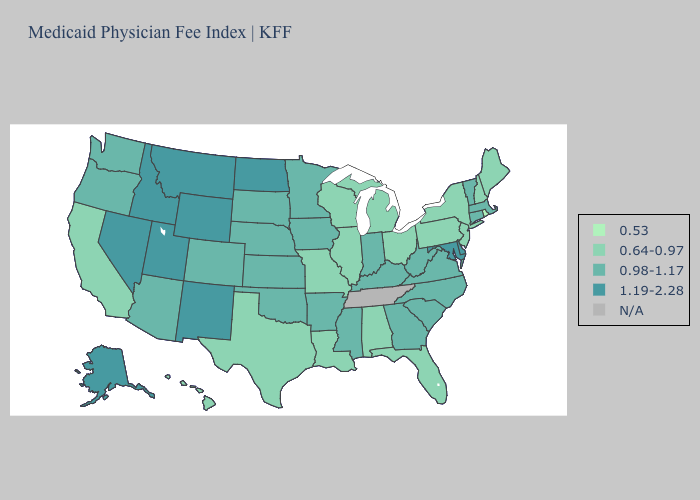Does the map have missing data?
Give a very brief answer. Yes. Does North Dakota have the highest value in the MidWest?
Give a very brief answer. Yes. Among the states that border New Mexico , does Utah have the lowest value?
Quick response, please. No. Among the states that border Delaware , which have the highest value?
Be succinct. Maryland. What is the highest value in the West ?
Be succinct. 1.19-2.28. Name the states that have a value in the range 1.19-2.28?
Be succinct. Alaska, Delaware, Idaho, Maryland, Montana, Nevada, New Mexico, North Dakota, Utah, Wyoming. Name the states that have a value in the range 0.64-0.97?
Write a very short answer. Alabama, California, Florida, Hawaii, Illinois, Louisiana, Maine, Michigan, Missouri, New Hampshire, New Jersey, New York, Ohio, Pennsylvania, Texas, Wisconsin. What is the lowest value in the MidWest?
Write a very short answer. 0.64-0.97. Among the states that border North Carolina , which have the lowest value?
Short answer required. Georgia, South Carolina, Virginia. What is the highest value in the USA?
Be succinct. 1.19-2.28. What is the value of Oregon?
Short answer required. 0.98-1.17. Which states hav the highest value in the West?
Answer briefly. Alaska, Idaho, Montana, Nevada, New Mexico, Utah, Wyoming. Which states have the highest value in the USA?
Answer briefly. Alaska, Delaware, Idaho, Maryland, Montana, Nevada, New Mexico, North Dakota, Utah, Wyoming. 